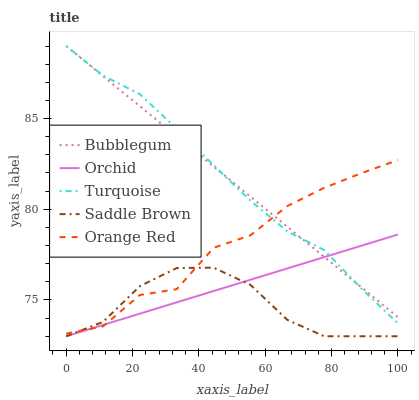Does Saddle Brown have the minimum area under the curve?
Answer yes or no. Yes. Does Turquoise have the maximum area under the curve?
Answer yes or no. Yes. Does Turquoise have the minimum area under the curve?
Answer yes or no. No. Does Saddle Brown have the maximum area under the curve?
Answer yes or no. No. Is Bubblegum the smoothest?
Answer yes or no. Yes. Is Orange Red the roughest?
Answer yes or no. Yes. Is Turquoise the smoothest?
Answer yes or no. No. Is Turquoise the roughest?
Answer yes or no. No. Does Saddle Brown have the lowest value?
Answer yes or no. Yes. Does Turquoise have the lowest value?
Answer yes or no. No. Does Bubblegum have the highest value?
Answer yes or no. Yes. Does Saddle Brown have the highest value?
Answer yes or no. No. Is Saddle Brown less than Bubblegum?
Answer yes or no. Yes. Is Bubblegum greater than Saddle Brown?
Answer yes or no. Yes. Does Bubblegum intersect Orange Red?
Answer yes or no. Yes. Is Bubblegum less than Orange Red?
Answer yes or no. No. Is Bubblegum greater than Orange Red?
Answer yes or no. No. Does Saddle Brown intersect Bubblegum?
Answer yes or no. No. 